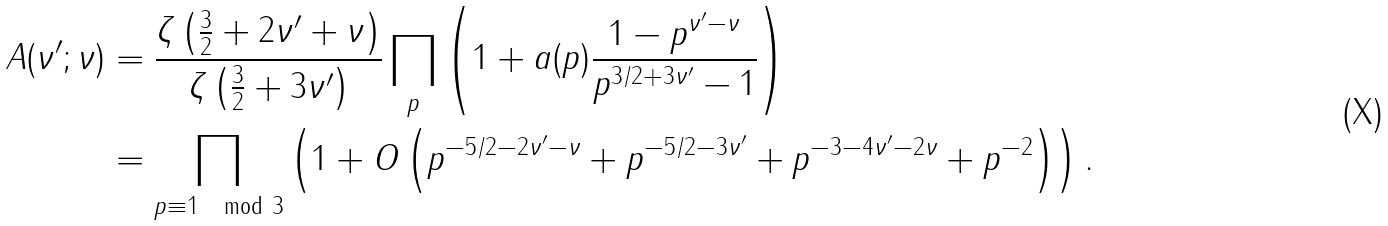Convert formula to latex. <formula><loc_0><loc_0><loc_500><loc_500>A ( \nu ^ { \prime } ; \nu ) & = \frac { \zeta \left ( \frac { 3 } { 2 } + 2 \nu ^ { \prime } + \nu \right ) } { \zeta \left ( \frac { 3 } { 2 } + 3 \nu ^ { \prime } \right ) } \prod _ { p } \left ( 1 + a ( p ) \frac { 1 - p ^ { \nu ^ { \prime } - \nu } } { p ^ { 3 / 2 + 3 \nu ^ { \prime } } - 1 } \right ) \\ & = \prod _ { p \equiv 1 \mod 3 } \left ( 1 + O \left ( p ^ { - 5 / 2 - 2 \nu ^ { \prime } - \nu } + p ^ { - 5 / 2 - 3 \nu ^ { \prime } } + p ^ { - 3 - 4 \nu ^ { \prime } - 2 \nu } + p ^ { - 2 } \right ) \right ) .</formula> 